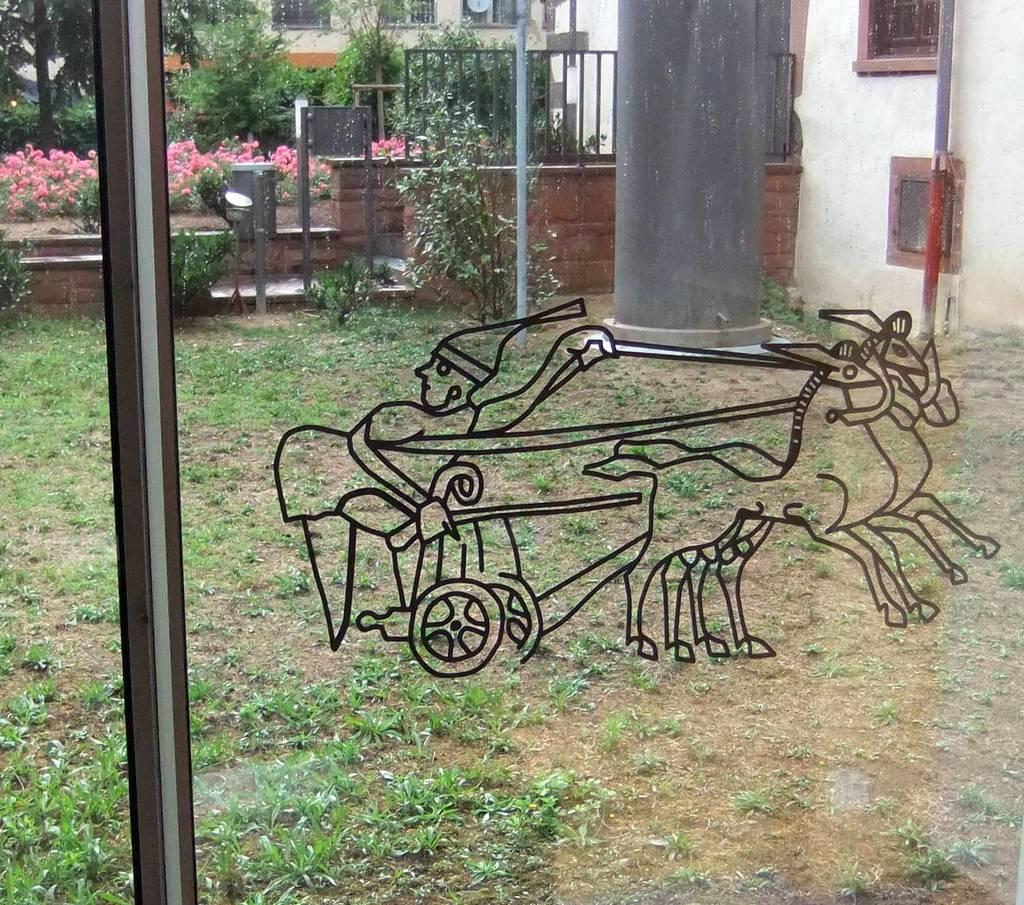What type of door is visible in the image? There is a glass door in the image. What is depicted on the glass door? There is a painting of horses, a cart, and a man on the door. What can be seen in the background of the image? There is a land pole, trees, and houses in the background of the image. Where is the hole in the image? There is no hole present in the image. What type of chalk is being used by the man in the painting on the door? There is no chalk visible in the image, as the man in the painting is not holding or using any chalk. 